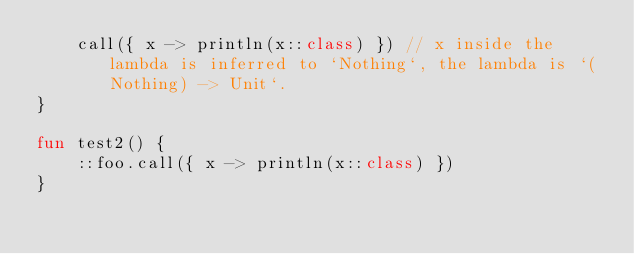Convert code to text. <code><loc_0><loc_0><loc_500><loc_500><_Kotlin_>    call({ x -> println(x::class) }) // x inside the lambda is inferred to `Nothing`, the lambda is `(Nothing) -> Unit`.
}

fun test2() {
    ::foo.call({ x -> println(x::class) })
}
</code> 